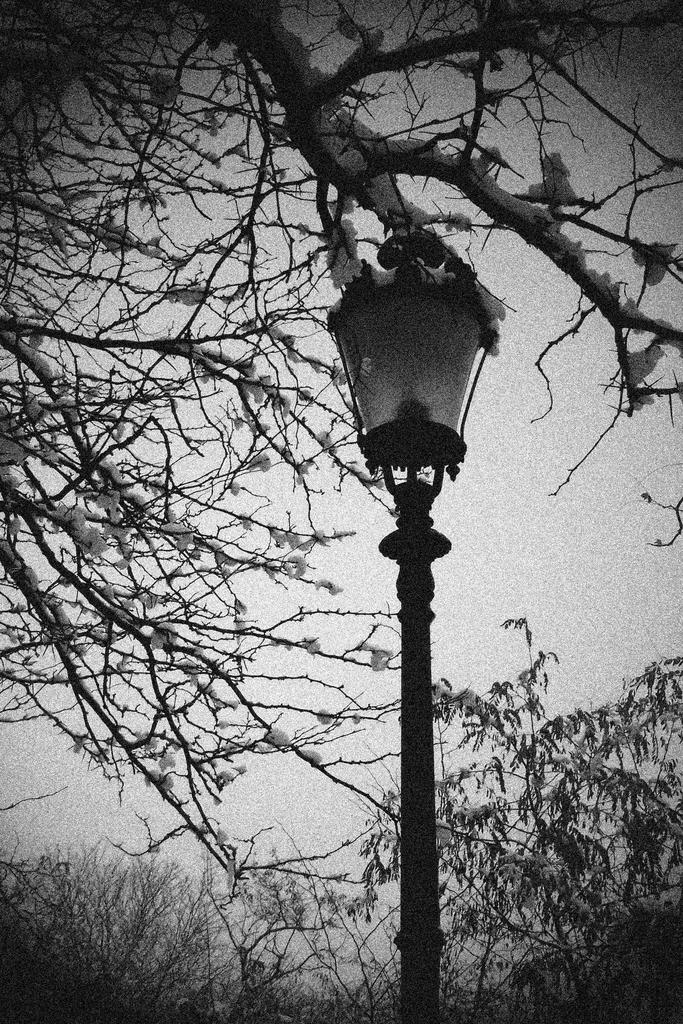What is attached to the pole in the image? There is a lamp attached to the pole in the image. What else can be seen near the pole? There is a part of a tree beside the pole. What type of vegetation is visible behind the pole? There are plants visible behind the pole. What is visible in the background of the image? The sky is visible in the image. What type of bun is being used to hold the gate open in the image? There is no gate or bun present in the image. 